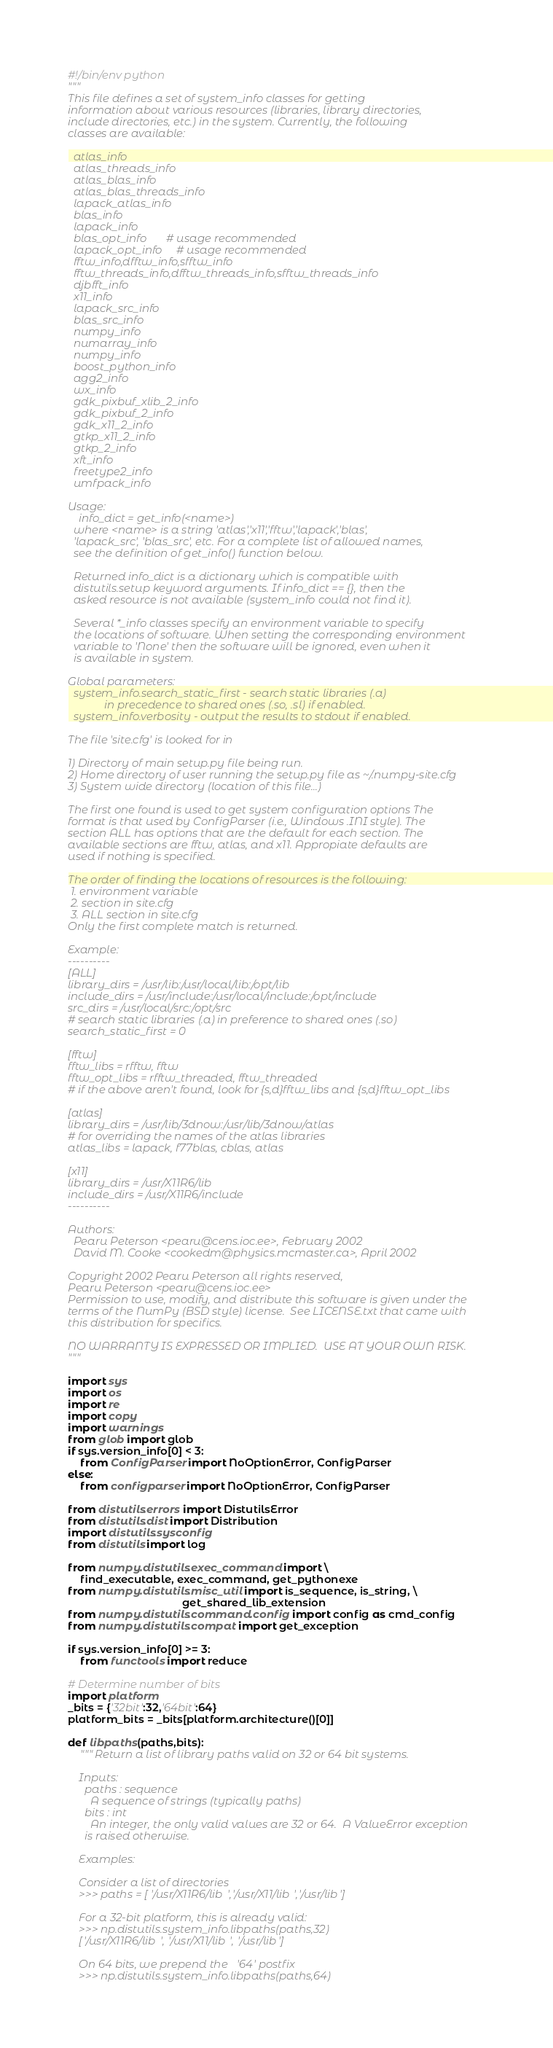Convert code to text. <code><loc_0><loc_0><loc_500><loc_500><_Python_>#!/bin/env python
"""
This file defines a set of system_info classes for getting
information about various resources (libraries, library directories,
include directories, etc.) in the system. Currently, the following
classes are available:

  atlas_info
  atlas_threads_info
  atlas_blas_info
  atlas_blas_threads_info
  lapack_atlas_info
  blas_info
  lapack_info
  blas_opt_info       # usage recommended
  lapack_opt_info     # usage recommended
  fftw_info,dfftw_info,sfftw_info
  fftw_threads_info,dfftw_threads_info,sfftw_threads_info
  djbfft_info
  x11_info
  lapack_src_info
  blas_src_info
  numpy_info
  numarray_info
  numpy_info
  boost_python_info
  agg2_info
  wx_info
  gdk_pixbuf_xlib_2_info
  gdk_pixbuf_2_info
  gdk_x11_2_info
  gtkp_x11_2_info
  gtkp_2_info
  xft_info
  freetype2_info
  umfpack_info

Usage:
    info_dict = get_info(<name>)
  where <name> is a string 'atlas','x11','fftw','lapack','blas',
  'lapack_src', 'blas_src', etc. For a complete list of allowed names,
  see the definition of get_info() function below.

  Returned info_dict is a dictionary which is compatible with
  distutils.setup keyword arguments. If info_dict == {}, then the
  asked resource is not available (system_info could not find it).

  Several *_info classes specify an environment variable to specify
  the locations of software. When setting the corresponding environment
  variable to 'None' then the software will be ignored, even when it
  is available in system.

Global parameters:
  system_info.search_static_first - search static libraries (.a)
             in precedence to shared ones (.so, .sl) if enabled.
  system_info.verbosity - output the results to stdout if enabled.

The file 'site.cfg' is looked for in

1) Directory of main setup.py file being run.
2) Home directory of user running the setup.py file as ~/.numpy-site.cfg
3) System wide directory (location of this file...)

The first one found is used to get system configuration options The
format is that used by ConfigParser (i.e., Windows .INI style). The
section ALL has options that are the default for each section. The
available sections are fftw, atlas, and x11. Appropiate defaults are
used if nothing is specified.

The order of finding the locations of resources is the following:
 1. environment variable
 2. section in site.cfg
 3. ALL section in site.cfg
Only the first complete match is returned.

Example:
----------
[ALL]
library_dirs = /usr/lib:/usr/local/lib:/opt/lib
include_dirs = /usr/include:/usr/local/include:/opt/include
src_dirs = /usr/local/src:/opt/src
# search static libraries (.a) in preference to shared ones (.so)
search_static_first = 0

[fftw]
fftw_libs = rfftw, fftw
fftw_opt_libs = rfftw_threaded, fftw_threaded
# if the above aren't found, look for {s,d}fftw_libs and {s,d}fftw_opt_libs

[atlas]
library_dirs = /usr/lib/3dnow:/usr/lib/3dnow/atlas
# for overriding the names of the atlas libraries
atlas_libs = lapack, f77blas, cblas, atlas

[x11]
library_dirs = /usr/X11R6/lib
include_dirs = /usr/X11R6/include
----------

Authors:
  Pearu Peterson <pearu@cens.ioc.ee>, February 2002
  David M. Cooke <cookedm@physics.mcmaster.ca>, April 2002

Copyright 2002 Pearu Peterson all rights reserved,
Pearu Peterson <pearu@cens.ioc.ee>
Permission to use, modify, and distribute this software is given under the
terms of the NumPy (BSD style) license.  See LICENSE.txt that came with
this distribution for specifics.

NO WARRANTY IS EXPRESSED OR IMPLIED.  USE AT YOUR OWN RISK.
"""

import sys
import os
import re
import copy
import warnings
from glob import glob
if sys.version_info[0] < 3:
    from ConfigParser import NoOptionError, ConfigParser
else:
    from configparser import NoOptionError, ConfigParser

from distutils.errors import DistutilsError
from distutils.dist import Distribution
import distutils.sysconfig
from distutils import log

from numpy.distutils.exec_command import \
    find_executable, exec_command, get_pythonexe
from numpy.distutils.misc_util import is_sequence, is_string, \
                                      get_shared_lib_extension
from numpy.distutils.command.config import config as cmd_config
from numpy.distutils.compat import get_exception

if sys.version_info[0] >= 3:
    from functools import reduce

# Determine number of bits
import platform
_bits = {'32bit':32,'64bit':64}
platform_bits = _bits[platform.architecture()[0]]

def libpaths(paths,bits):
    """Return a list of library paths valid on 32 or 64 bit systems.

    Inputs:
      paths : sequence
        A sequence of strings (typically paths)
      bits : int
        An integer, the only valid values are 32 or 64.  A ValueError exception
      is raised otherwise.

    Examples:

    Consider a list of directories
    >>> paths = ['/usr/X11R6/lib','/usr/X11/lib','/usr/lib']

    For a 32-bit platform, this is already valid:
    >>> np.distutils.system_info.libpaths(paths,32)
    ['/usr/X11R6/lib', '/usr/X11/lib', '/usr/lib']

    On 64 bits, we prepend the '64' postfix
    >>> np.distutils.system_info.libpaths(paths,64)</code> 